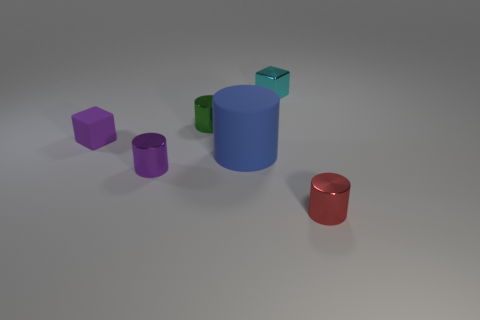Add 2 tiny brown cylinders. How many objects exist? 8 Subtract all big blue rubber cylinders. How many cylinders are left? 3 Subtract all purple cylinders. How many cylinders are left? 3 Subtract all blocks. How many objects are left? 4 Subtract 2 cubes. How many cubes are left? 0 Subtract all brown cylinders. Subtract all green blocks. How many cylinders are left? 4 Subtract all red blocks. How many red cylinders are left? 1 Subtract all green shiny things. Subtract all big cylinders. How many objects are left? 4 Add 4 blocks. How many blocks are left? 6 Add 5 tiny green spheres. How many tiny green spheres exist? 5 